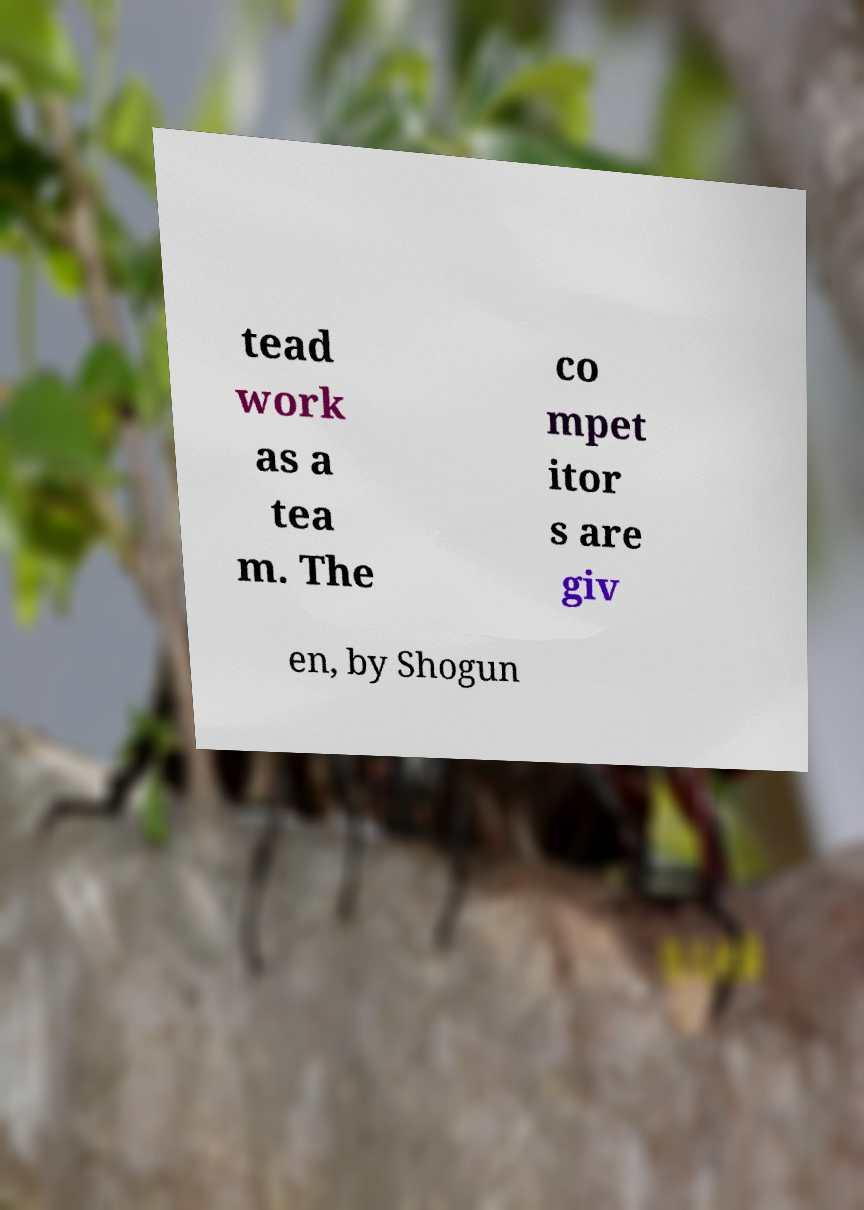I need the written content from this picture converted into text. Can you do that? tead work as a tea m. The co mpet itor s are giv en, by Shogun 